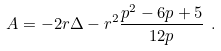<formula> <loc_0><loc_0><loc_500><loc_500>A = - 2 r \Delta - r ^ { 2 } \frac { p ^ { 2 } - 6 p + 5 } { 1 2 p } \ .</formula> 